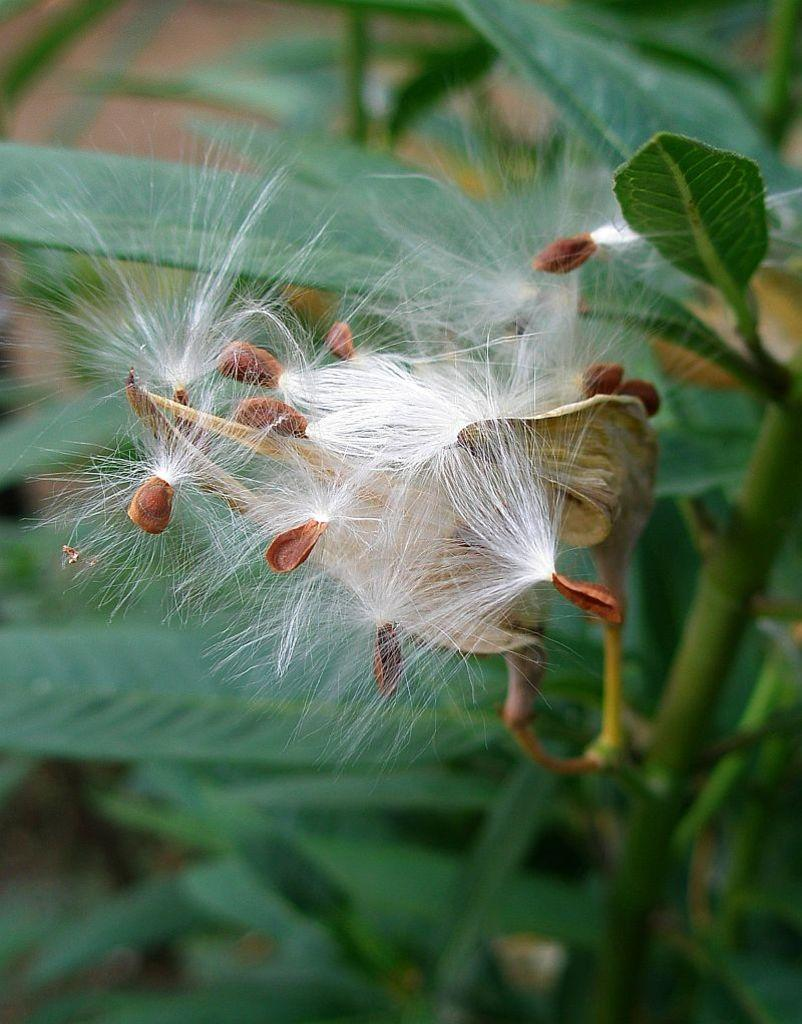What is the focus of the image? The image is zoomed in on a white color object. What is the nature of the white object? The white object appears to be flowers and buds. What other colors can be seen in the image? Green leaves are visible in the image. What else is present in the image besides the flowers and leaves? Plant stems are present in the image. What type of pencil can be seen in the image? There is no pencil present in the image; it features flowers, buds, leaves, and stems. Is there a book visible in the image? There is no book present in the image. 